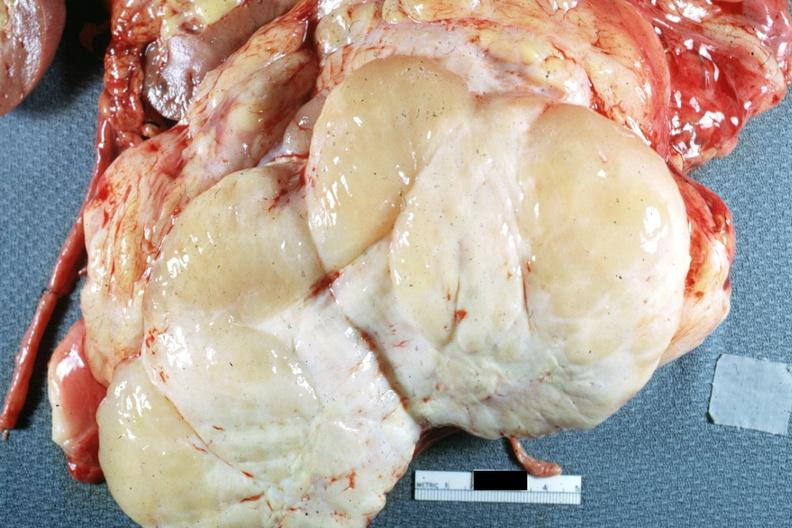s abdomen present?
Answer the question using a single word or phrase. Yes 